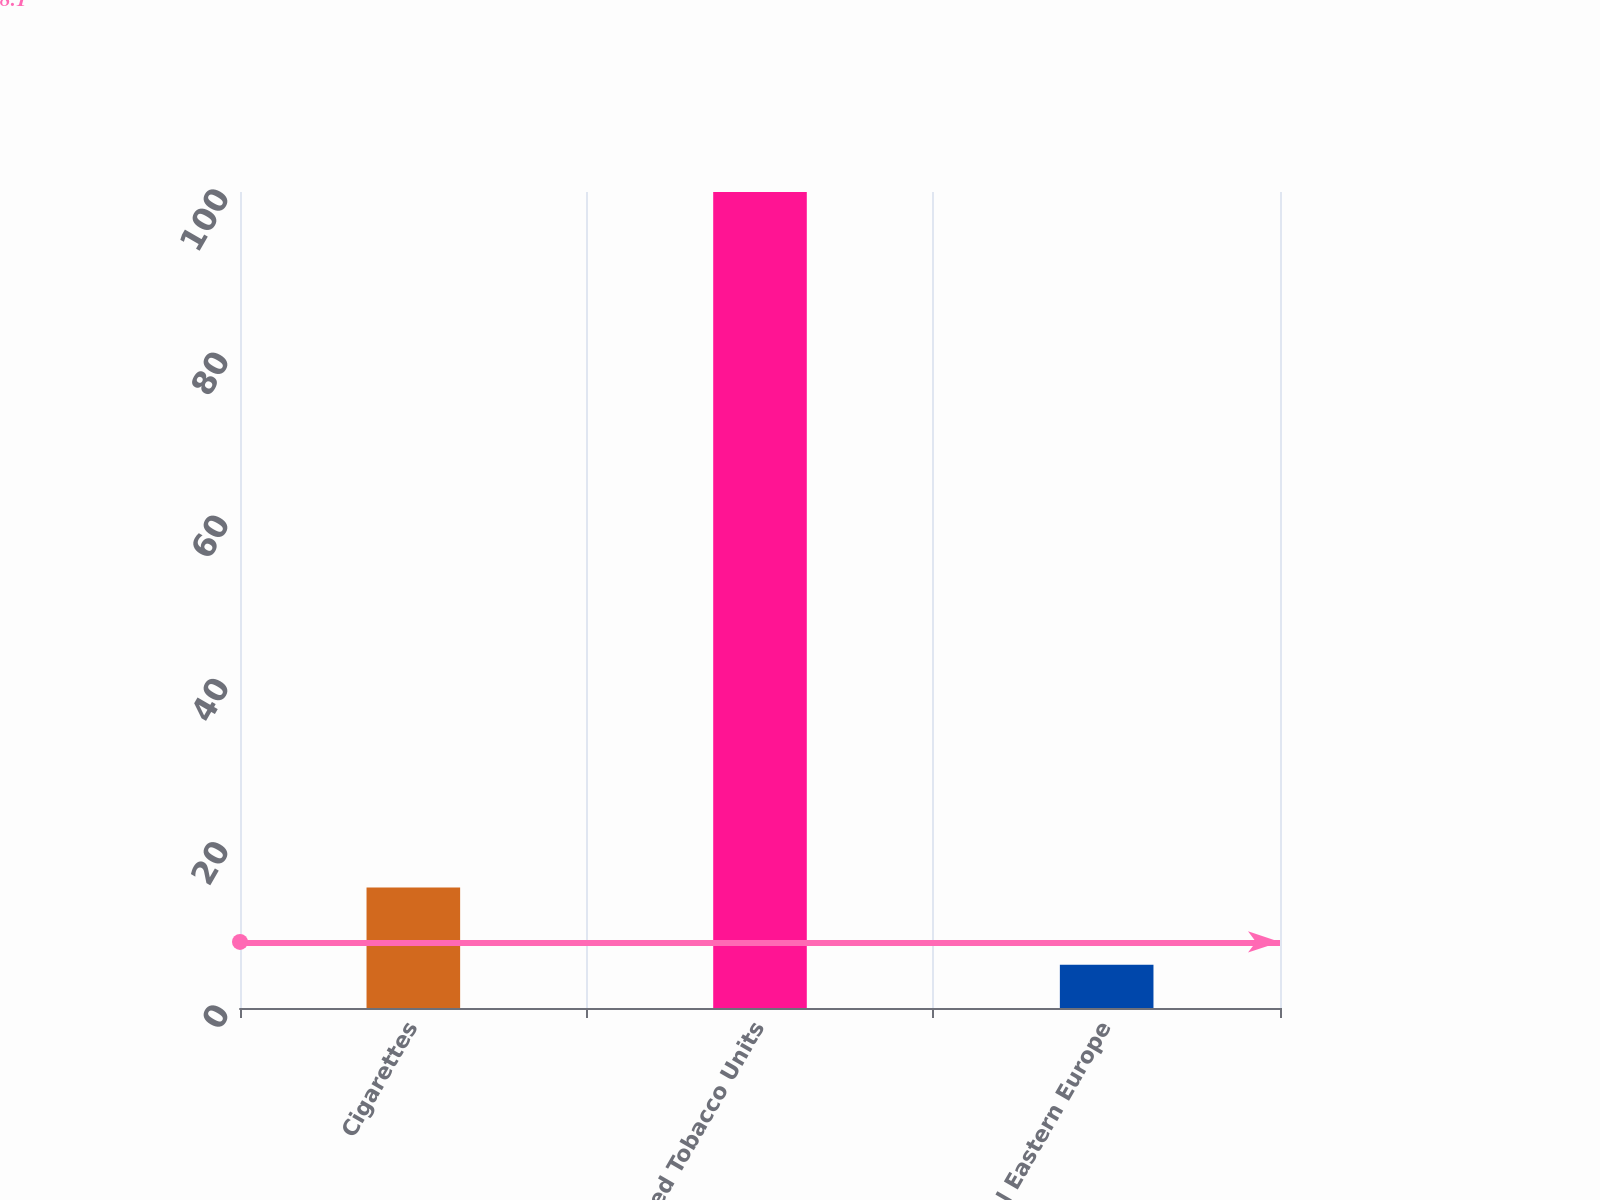Convert chart to OTSL. <chart><loc_0><loc_0><loc_500><loc_500><bar_chart><fcel>Cigarettes<fcel>Heated Tobacco Units<fcel>Total Eastern Europe<nl><fcel>14.77<fcel>100<fcel>5.3<nl></chart> 